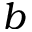<formula> <loc_0><loc_0><loc_500><loc_500>b</formula> 